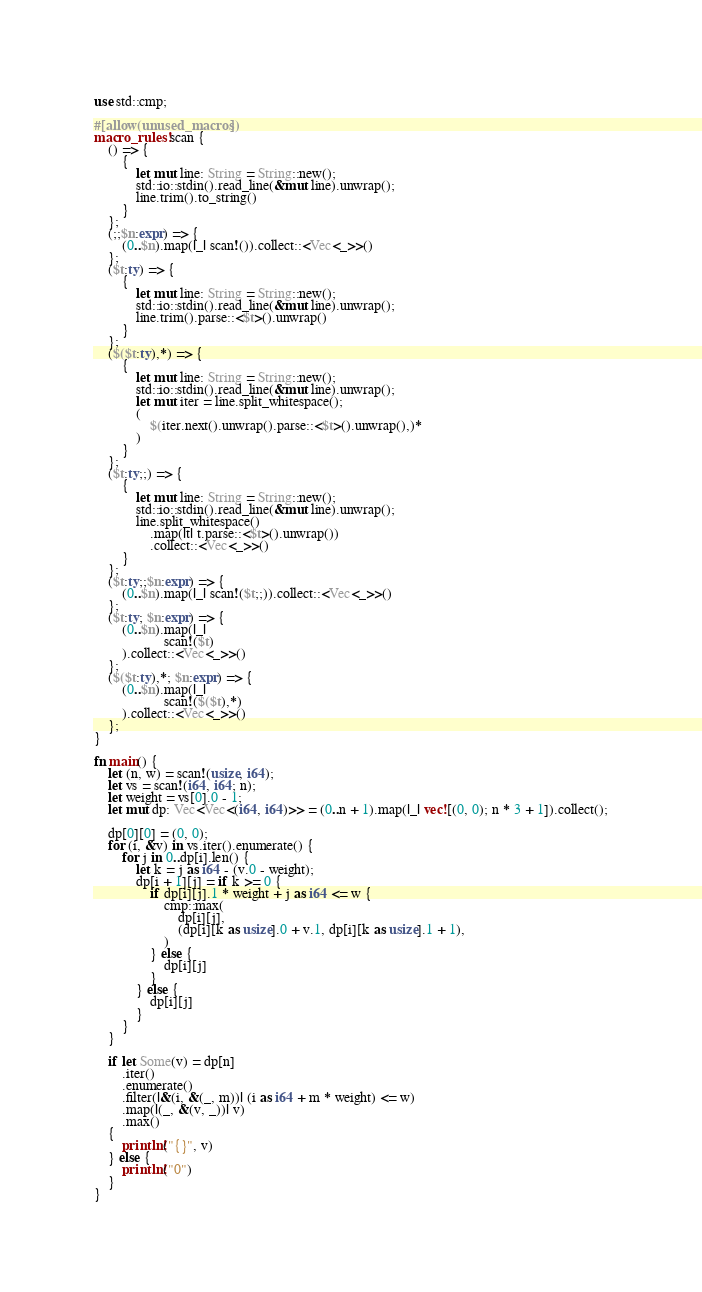<code> <loc_0><loc_0><loc_500><loc_500><_Rust_>use std::cmp;

#[allow(unused_macros)]
macro_rules! scan {
    () => {
        {
            let mut line: String = String::new();
            std::io::stdin().read_line(&mut line).unwrap();
            line.trim().to_string()
        }
    };
    (;;$n:expr) => {
        (0..$n).map(|_| scan!()).collect::<Vec<_>>()
    };
    ($t:ty) => {
        {
            let mut line: String = String::new();
            std::io::stdin().read_line(&mut line).unwrap();
            line.trim().parse::<$t>().unwrap()
        }
    };
    ($($t:ty),*) => {
        {
            let mut line: String = String::new();
            std::io::stdin().read_line(&mut line).unwrap();
            let mut iter = line.split_whitespace();
            (
                $(iter.next().unwrap().parse::<$t>().unwrap(),)*
            )
        }
    };
    ($t:ty;;) => {
        {
            let mut line: String = String::new();
            std::io::stdin().read_line(&mut line).unwrap();
            line.split_whitespace()
                .map(|t| t.parse::<$t>().unwrap())
                .collect::<Vec<_>>()
        }
    };
    ($t:ty;;$n:expr) => {
        (0..$n).map(|_| scan!($t;;)).collect::<Vec<_>>()
    };
    ($t:ty; $n:expr) => {
        (0..$n).map(|_|
                    scan!($t)
        ).collect::<Vec<_>>()
    };
    ($($t:ty),*; $n:expr) => {
        (0..$n).map(|_|
                    scan!($($t),*)
        ).collect::<Vec<_>>()
    };
}

fn main() {
    let (n, w) = scan!(usize, i64);
    let vs = scan!(i64, i64; n);
    let weight = vs[0].0 - 1;
    let mut dp: Vec<Vec<(i64, i64)>> = (0..n + 1).map(|_| vec![(0, 0); n * 3 + 1]).collect();

    dp[0][0] = (0, 0);
    for (i, &v) in vs.iter().enumerate() {
        for j in 0..dp[i].len() {
            let k = j as i64 - (v.0 - weight);
            dp[i + 1][j] = if k >= 0 {
                if dp[i][j].1 * weight + j as i64 <= w {
                    cmp::max(
                        dp[i][j],
                        (dp[i][k as usize].0 + v.1, dp[i][k as usize].1 + 1),
                    )
                } else {
                    dp[i][j]
                }
            } else {
                dp[i][j]
            }
        }
    }

    if let Some(v) = dp[n]
        .iter()
        .enumerate()
        .filter(|&(i, &(_, m))| (i as i64 + m * weight) <= w)
        .map(|(_, &(v, _))| v)
        .max()
    {
        println!("{}", v)
    } else {
        println!("0")
    }
}
</code> 